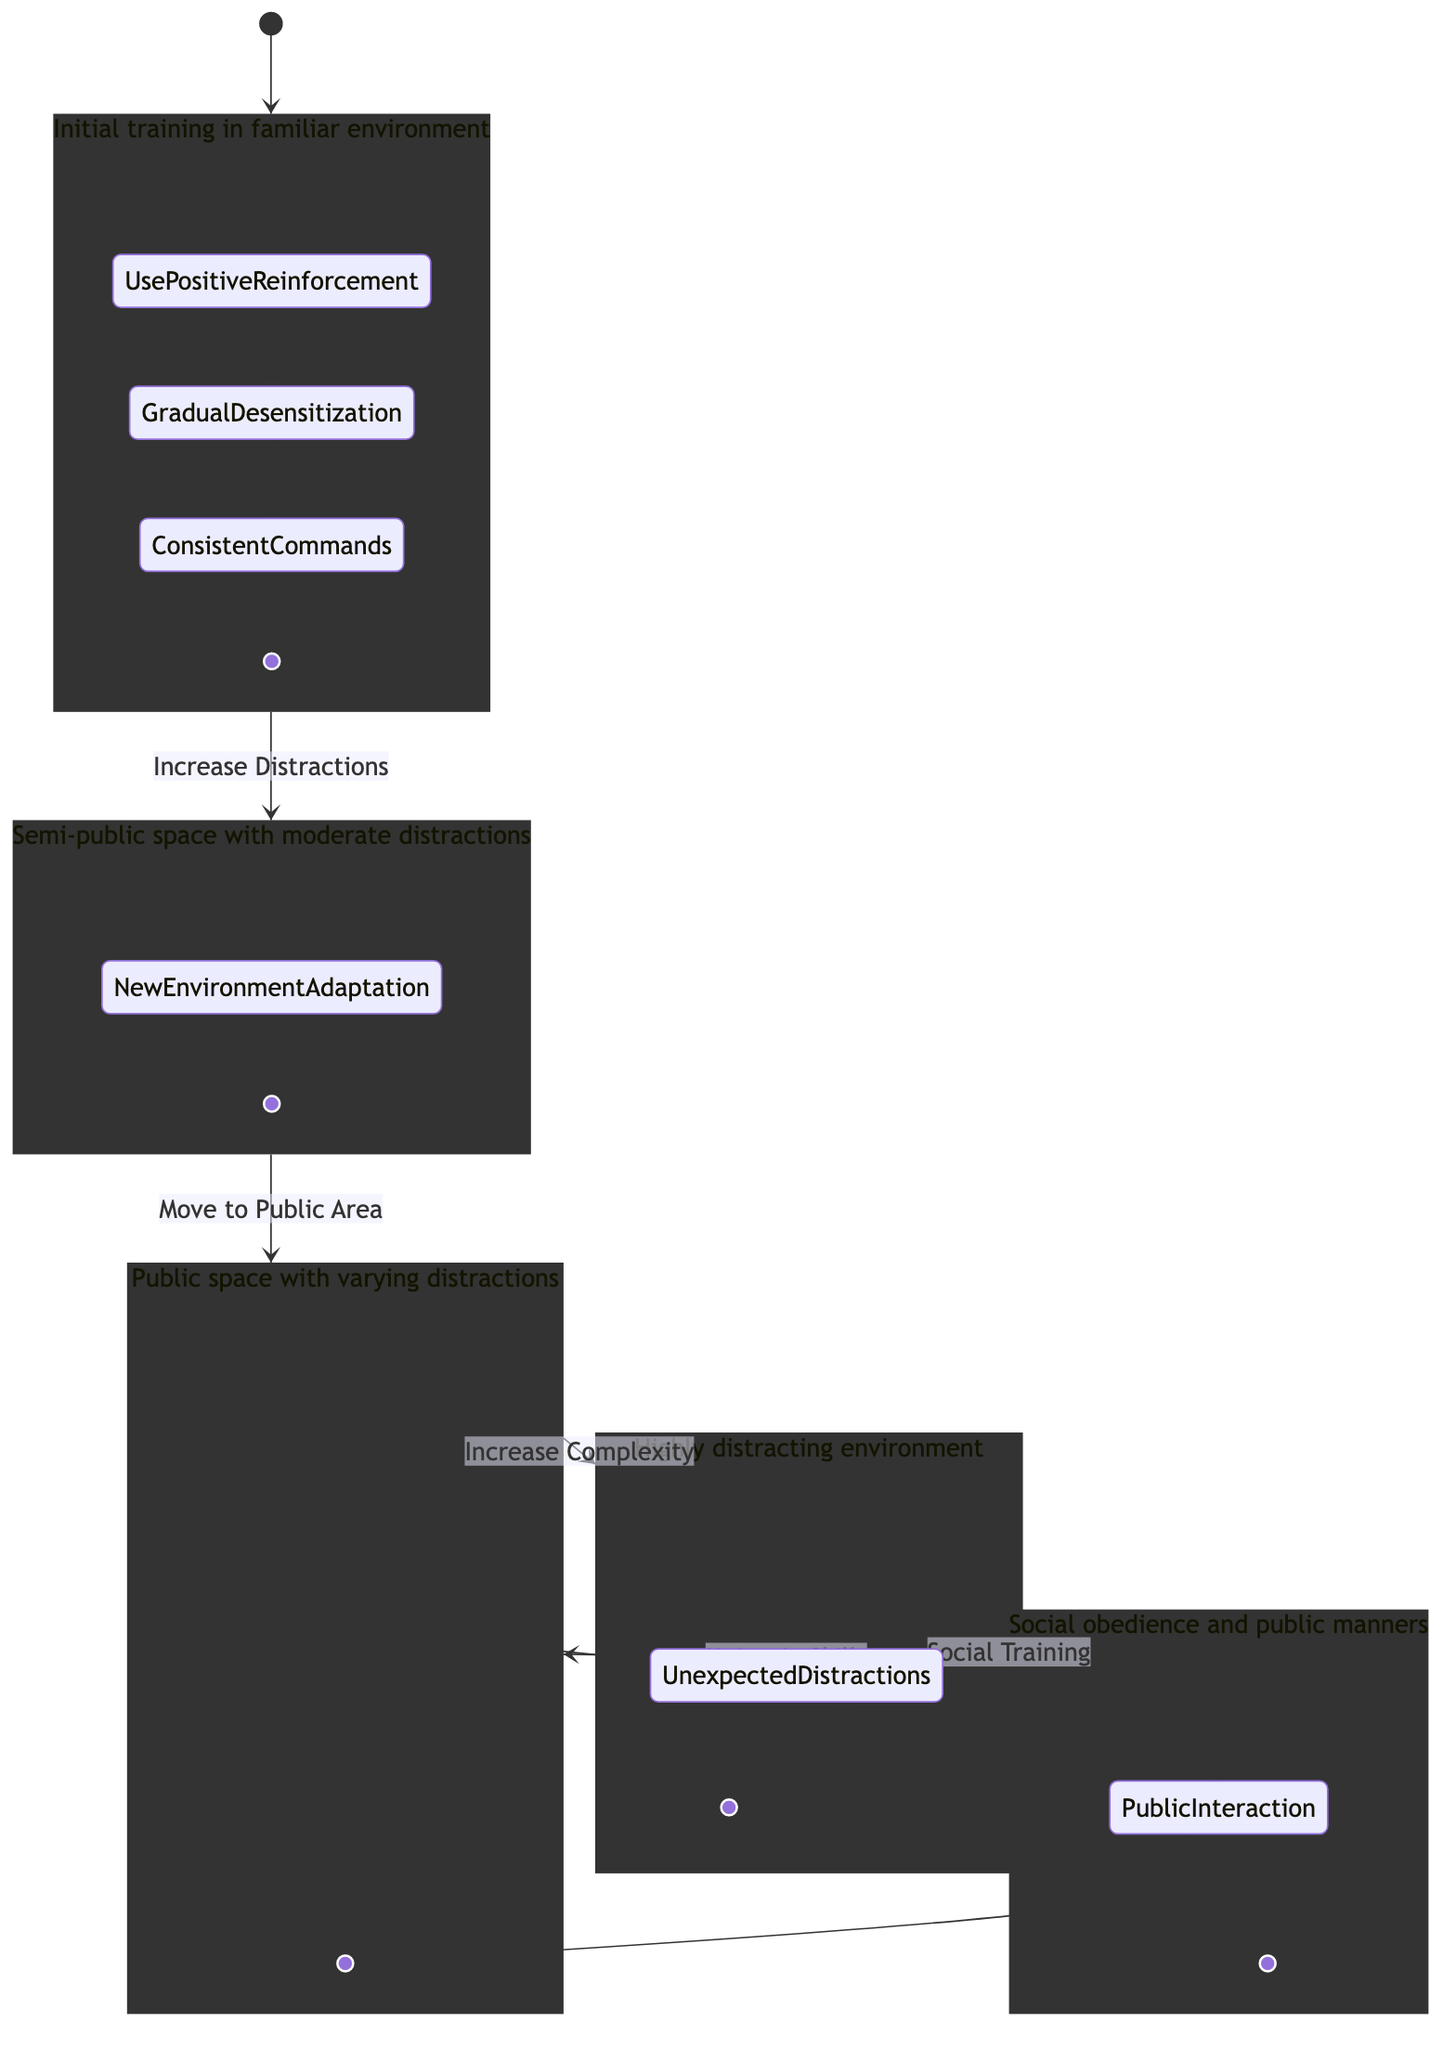What is the initial state of the training process? The diagram starts at the state labeled "Home Training," which represents the initial controlled training environment before progressing to more challenging settings.
Answer: Home Training What transition leads from Front Yard to Local Park? The transition labeled "Move to Public Area" indicates that the training progresses from the Front Yard to the Local Park, signifying an increase in distractions.
Answer: Move to Public Area How many training states are depicted in the diagram? By counting the states listed in the diagram, including Home Training, Front Yard, Local Park, Busy Street, and Dog-Friendly Cafe, there are a total of five training states present.
Answer: 5 What action is associated with the Home Training state? Examining the Home Training state's actions, it starts with "Use Positive Reinforcement," which is the first action to be conducted in this familiar environment.
Answer: Use Positive Reinforcement What is the last state before returning to Local Park? From the diagram, the last state before returning to the Local Park is "Dog-Friendly Cafe," indicating a focus on social obedience and public manners in that specific location.
Answer: Dog-Friendly Cafe What type of training occurs at the Busy Street? The Busy Street state indicates that the training conducted here is advanced, which is denoted by the transition labeled "Increase Complexity," showing that the dog is exposed to more challenging distractions.
Answer: Advanced training Which state involves social interaction? The Dog-Friendly Cafe state includes interaction with strangers and other dogs, as indicated by the focus on social skills and obedience in a public space.
Answer: Dog-Friendly Cafe What is the purpose of the "Maintain Skills" transition? The transition "Maintain Skills" describes the importance of periodically revisiting less challenging environments, like the Local Park, to help reinforce the skills learned in more difficult settings.
Answer: Reinforce skills 